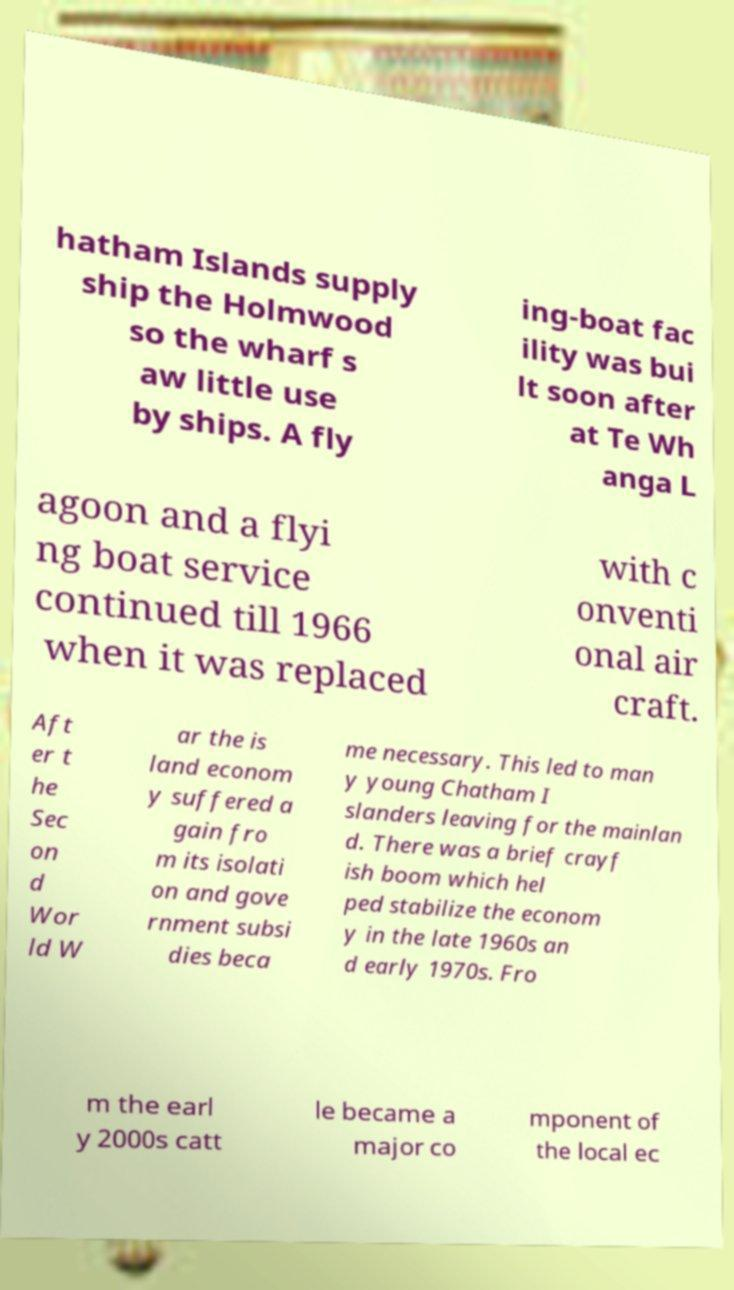Could you assist in decoding the text presented in this image and type it out clearly? hatham Islands supply ship the Holmwood so the wharf s aw little use by ships. A fly ing-boat fac ility was bui lt soon after at Te Wh anga L agoon and a flyi ng boat service continued till 1966 when it was replaced with c onventi onal air craft. Aft er t he Sec on d Wor ld W ar the is land econom y suffered a gain fro m its isolati on and gove rnment subsi dies beca me necessary. This led to man y young Chatham I slanders leaving for the mainlan d. There was a brief crayf ish boom which hel ped stabilize the econom y in the late 1960s an d early 1970s. Fro m the earl y 2000s catt le became a major co mponent of the local ec 